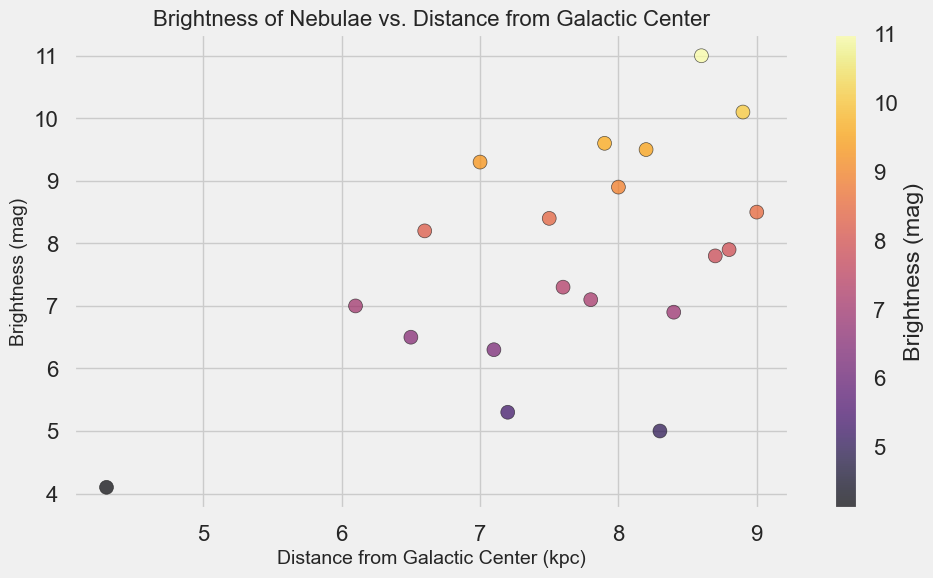How many nebulae have a brightness magnitude of less than 7? First, identify all the nebulae whose brightness magnitude is less than 7 from the plot. The data points corresponding to these nebulae will be vertically below the level 7 on the y-axis. Count these data points.
Answer: 5 Which nebula is the closest to the galactic center and what is its brightness? Identify the data point with the smallest x-coordinate value (closest distance from the galactic center). Check the color and position of this point to determine the corresponding brightness value.
Answer: Tarantula, 4.1 mag Is there a general trend between brightness and distance from the galactic center? Observe the overall distribution of the data points in the scatter plot. Look for any patterns or noticeable trends between the x and y coordinates. If brightness increases as distance decreases or vice versa, mention that.
Answer: No clear trend Which nebula is the faintest among those at a distance between 7 and 8 kpc from the galactic center? First, identify the nebulae within a distance range of 7 to 8 kpc on the x-axis. Then, among these points, find the one with the highest y-coordinate value (faintest brightness).
Answer: Rosette, 8.9 mag List all nebulae brighter than 6 magnitude and provide their distances from the galactic center. Identify all data points with a y-coordinate (brightness) less than 6. Then, list these nebulae along with their corresponding x-coordinates (distances from the galactic center).
Answer: Orion (8.3 kpc), Tarantula (4.3 kpc), Lagoon (7.2 kpc) Which nebula has the highest brightness and what is its distance from the galactic center? Identify the data point with the lowest y-coordinate value (highest brightness). Check the position of this point to determine its corresponding distance from the galactic center.
Answer: Tarantula, 4.3 kpc Are there more nebulae with a distance greater than 8 kpc or less than 8 kpc from the galactic center? Count the number of data points with x-coordinates greater than 8 kpc and compare this with the count of points with x-coordinates less than 8 kpc.
Answer: Less than 8 kpc What is the average brightness of nebulae located within 7 kpc and 9 kpc from the galactic center? Identify all the data points that fall within the 7 to 9 kpc distance range on the x-axis. Add their y-coordinates (brightness values) and divide by the number of such nebulae to find the average.
Answer: (7.0 + 9.0 + 8.9 + 8.2 + 8.0 + 8.7 + 8.8 + 8.4 + 9.6 + 8.6 + 9.3) / 11 = 8.51 mag 